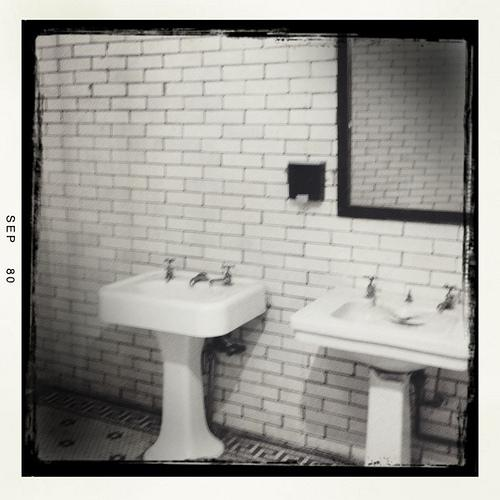Question: where are the sinks?
Choices:
A. In the bathroom.
B. In the kitchen.
C. On the wall.
D. On the patio.
Answer with the letter. Answer: C Question: how many sinks are in the photo?
Choices:
A. 5.
B. 9.
C. 2.
D. 8.
Answer with the letter. Answer: C Question: what color are the sinks?
Choices:
A. Black.
B. White.
C. Grey.
D. Purple.
Answer with the letter. Answer: B 